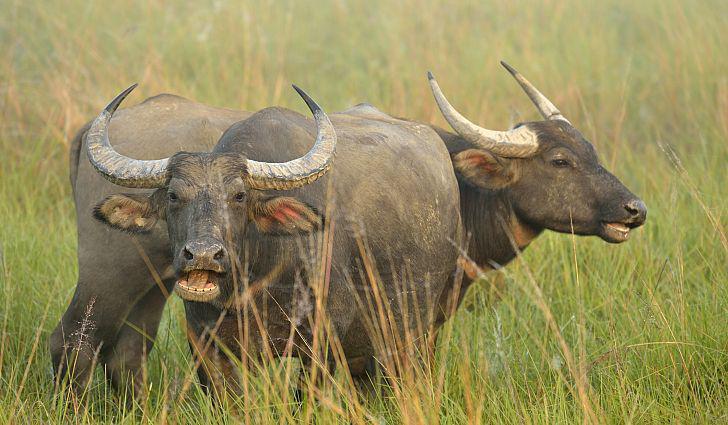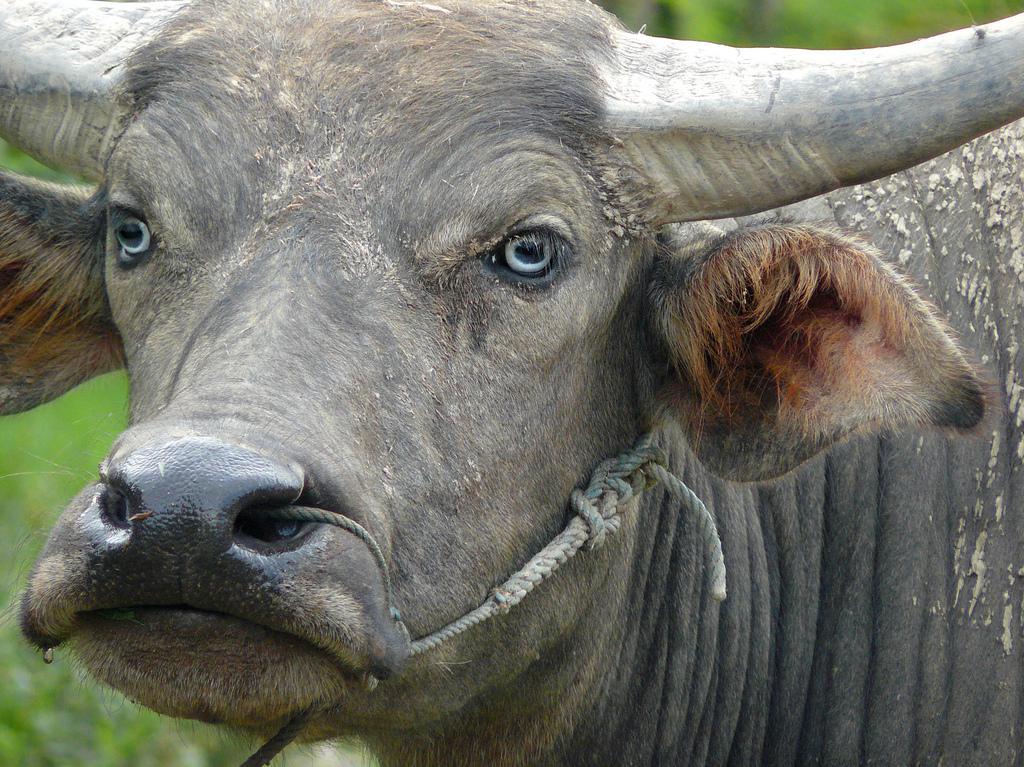The first image is the image on the left, the second image is the image on the right. Assess this claim about the two images: "An image shows a water buffalo standing in water.". Correct or not? Answer yes or no. No. The first image is the image on the left, the second image is the image on the right. Examine the images to the left and right. Is the description "A water buffalo is standing in water." accurate? Answer yes or no. No. 